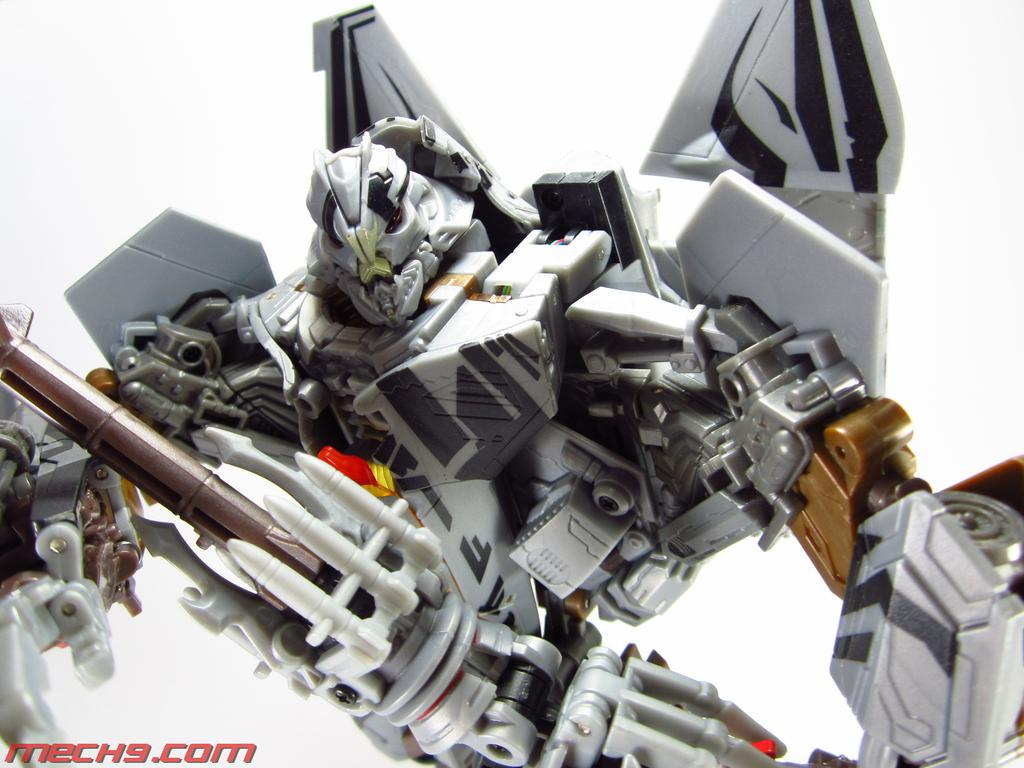What object can be seen in the image? There is a toy in the image. Where is the text located in the image? The text is in the bottom left of the image. What color is the background of the image? The background of the image is white. How does the brain generate heat in the image? There is no brain present in the image, so it cannot generate heat. 